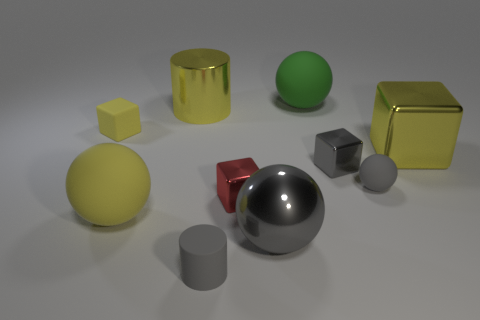What is the material of the large sphere that is behind the tiny block behind the gray shiny block?
Offer a terse response. Rubber. What is the size of the red thing?
Offer a very short reply. Small. What is the size of the yellow sphere that is made of the same material as the tiny gray cylinder?
Ensure brevity in your answer.  Large. There is a block that is on the left side of the gray rubber cylinder; is it the same size as the big yellow ball?
Ensure brevity in your answer.  No. There is a tiny gray object in front of the large metal thing in front of the gray rubber object right of the large green object; what shape is it?
Offer a very short reply. Cylinder. What number of objects are either rubber objects or tiny matte objects on the right side of the red shiny thing?
Your response must be concise. 5. How big is the yellow cube that is left of the large yellow cylinder?
Provide a short and direct response. Small. There is a small metallic object that is the same color as the rubber cylinder; what shape is it?
Provide a succinct answer. Cube. Are the small gray cylinder and the gray sphere that is behind the red thing made of the same material?
Your answer should be compact. Yes. What number of big yellow things are behind the metal cube that is to the right of the gray cube that is left of the large yellow metallic cube?
Your answer should be compact. 1. 